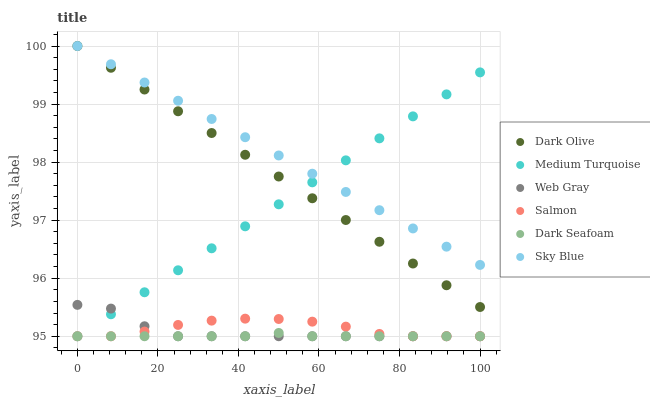Does Dark Seafoam have the minimum area under the curve?
Answer yes or no. Yes. Does Sky Blue have the maximum area under the curve?
Answer yes or no. Yes. Does Dark Olive have the minimum area under the curve?
Answer yes or no. No. Does Dark Olive have the maximum area under the curve?
Answer yes or no. No. Is Dark Olive the smoothest?
Answer yes or no. Yes. Is Web Gray the roughest?
Answer yes or no. Yes. Is Salmon the smoothest?
Answer yes or no. No. Is Salmon the roughest?
Answer yes or no. No. Does Web Gray have the lowest value?
Answer yes or no. Yes. Does Dark Olive have the lowest value?
Answer yes or no. No. Does Sky Blue have the highest value?
Answer yes or no. Yes. Does Salmon have the highest value?
Answer yes or no. No. Is Salmon less than Sky Blue?
Answer yes or no. Yes. Is Sky Blue greater than Dark Seafoam?
Answer yes or no. Yes. Does Medium Turquoise intersect Web Gray?
Answer yes or no. Yes. Is Medium Turquoise less than Web Gray?
Answer yes or no. No. Is Medium Turquoise greater than Web Gray?
Answer yes or no. No. Does Salmon intersect Sky Blue?
Answer yes or no. No. 